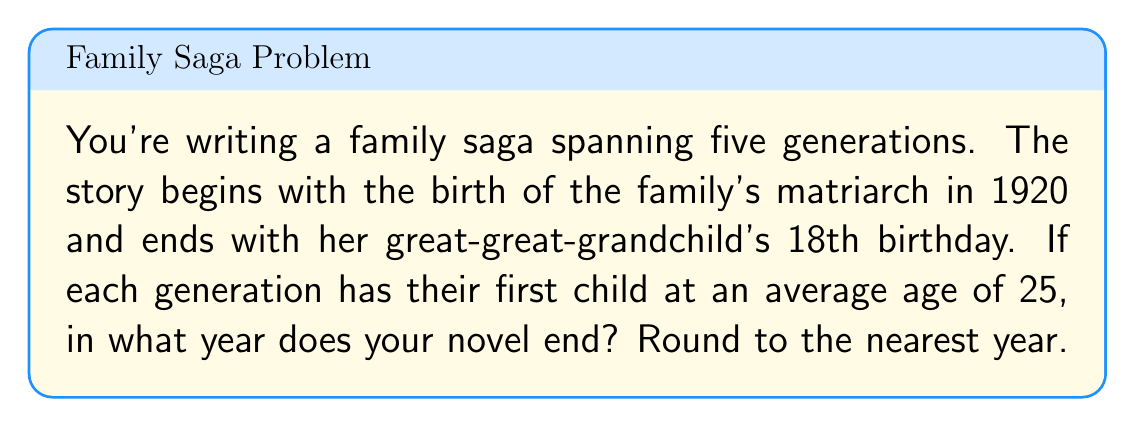Provide a solution to this math problem. Let's approach this step-by-step:

1) First, we need to calculate how many years pass from the matriarch's birth to the birth of her great-great-grandchild:

   $$ 25 \text{ years/generation} \times 4 \text{ generations} = 100 \text{ years} $$

2) So, the great-great-grandchild is born in:

   $$ 1920 + 100 = 2020 $$

3) The novel ends on the great-great-grandchild's 18th birthday, so we need to add 18 years:

   $$ 2020 + 18 = 2038 $$

Therefore, your novel ends in 2038.
Answer: 2038 